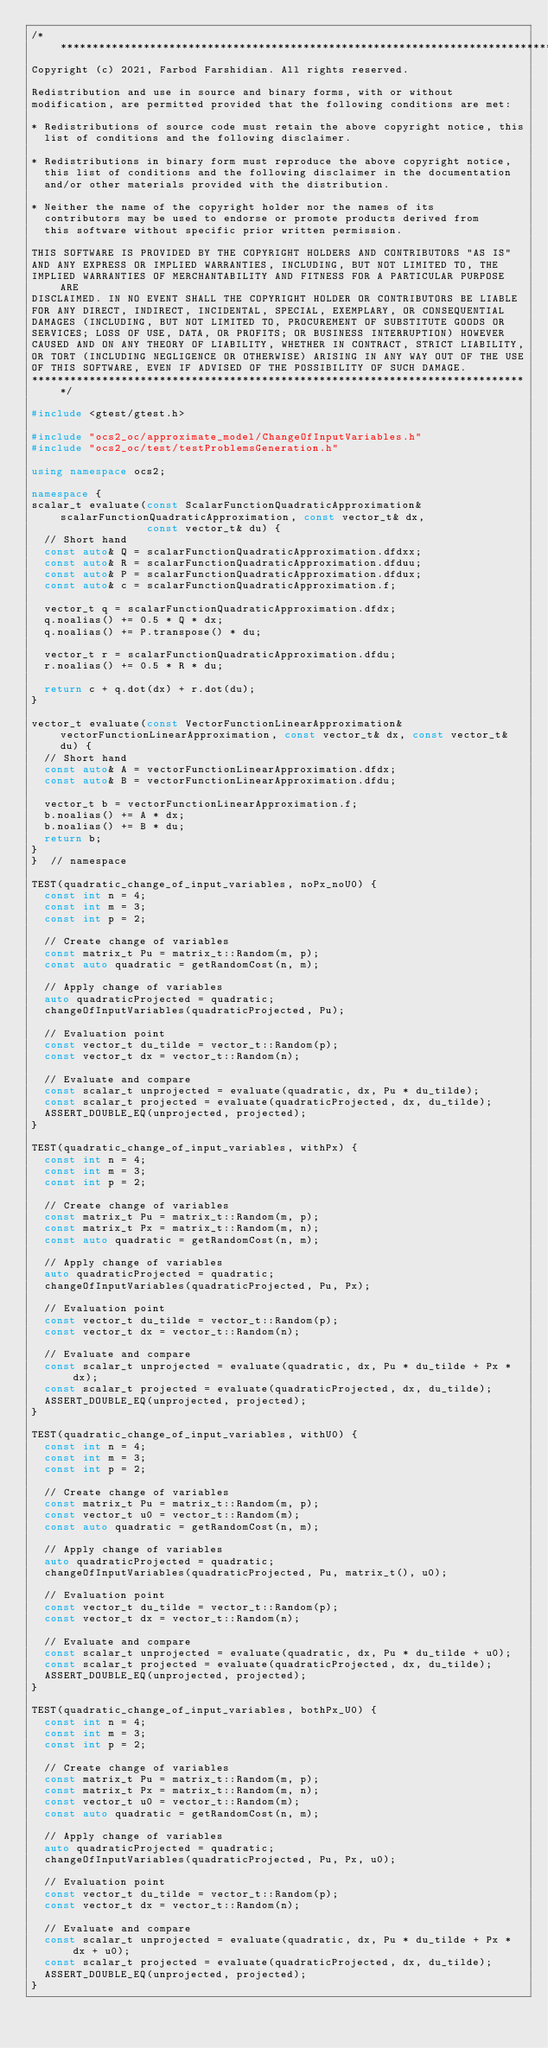<code> <loc_0><loc_0><loc_500><loc_500><_C++_>/******************************************************************************
Copyright (c) 2021, Farbod Farshidian. All rights reserved.

Redistribution and use in source and binary forms, with or without
modification, are permitted provided that the following conditions are met:

* Redistributions of source code must retain the above copyright notice, this
  list of conditions and the following disclaimer.

* Redistributions in binary form must reproduce the above copyright notice,
  this list of conditions and the following disclaimer in the documentation
  and/or other materials provided with the distribution.

* Neither the name of the copyright holder nor the names of its
  contributors may be used to endorse or promote products derived from
  this software without specific prior written permission.

THIS SOFTWARE IS PROVIDED BY THE COPYRIGHT HOLDERS AND CONTRIBUTORS "AS IS"
AND ANY EXPRESS OR IMPLIED WARRANTIES, INCLUDING, BUT NOT LIMITED TO, THE
IMPLIED WARRANTIES OF MERCHANTABILITY AND FITNESS FOR A PARTICULAR PURPOSE ARE
DISCLAIMED. IN NO EVENT SHALL THE COPYRIGHT HOLDER OR CONTRIBUTORS BE LIABLE
FOR ANY DIRECT, INDIRECT, INCIDENTAL, SPECIAL, EXEMPLARY, OR CONSEQUENTIAL
DAMAGES (INCLUDING, BUT NOT LIMITED TO, PROCUREMENT OF SUBSTITUTE GOODS OR
SERVICES; LOSS OF USE, DATA, OR PROFITS; OR BUSINESS INTERRUPTION) HOWEVER
CAUSED AND ON ANY THEORY OF LIABILITY, WHETHER IN CONTRACT, STRICT LIABILITY,
OR TORT (INCLUDING NEGLIGENCE OR OTHERWISE) ARISING IN ANY WAY OUT OF THE USE
OF THIS SOFTWARE, EVEN IF ADVISED OF THE POSSIBILITY OF SUCH DAMAGE.
******************************************************************************/

#include <gtest/gtest.h>

#include "ocs2_oc/approximate_model/ChangeOfInputVariables.h"
#include "ocs2_oc/test/testProblemsGeneration.h"

using namespace ocs2;

namespace {
scalar_t evaluate(const ScalarFunctionQuadraticApproximation& scalarFunctionQuadraticApproximation, const vector_t& dx,
                  const vector_t& du) {
  // Short hand
  const auto& Q = scalarFunctionQuadraticApproximation.dfdxx;
  const auto& R = scalarFunctionQuadraticApproximation.dfduu;
  const auto& P = scalarFunctionQuadraticApproximation.dfdux;
  const auto& c = scalarFunctionQuadraticApproximation.f;

  vector_t q = scalarFunctionQuadraticApproximation.dfdx;
  q.noalias() += 0.5 * Q * dx;
  q.noalias() += P.transpose() * du;

  vector_t r = scalarFunctionQuadraticApproximation.dfdu;
  r.noalias() += 0.5 * R * du;

  return c + q.dot(dx) + r.dot(du);
}

vector_t evaluate(const VectorFunctionLinearApproximation& vectorFunctionLinearApproximation, const vector_t& dx, const vector_t& du) {
  // Short hand
  const auto& A = vectorFunctionLinearApproximation.dfdx;
  const auto& B = vectorFunctionLinearApproximation.dfdu;

  vector_t b = vectorFunctionLinearApproximation.f;
  b.noalias() += A * dx;
  b.noalias() += B * du;
  return b;
}
}  // namespace

TEST(quadratic_change_of_input_variables, noPx_noU0) {
  const int n = 4;
  const int m = 3;
  const int p = 2;

  // Create change of variables
  const matrix_t Pu = matrix_t::Random(m, p);
  const auto quadratic = getRandomCost(n, m);

  // Apply change of variables
  auto quadraticProjected = quadratic;
  changeOfInputVariables(quadraticProjected, Pu);

  // Evaluation point
  const vector_t du_tilde = vector_t::Random(p);
  const vector_t dx = vector_t::Random(n);

  // Evaluate and compare
  const scalar_t unprojected = evaluate(quadratic, dx, Pu * du_tilde);
  const scalar_t projected = evaluate(quadraticProjected, dx, du_tilde);
  ASSERT_DOUBLE_EQ(unprojected, projected);
}

TEST(quadratic_change_of_input_variables, withPx) {
  const int n = 4;
  const int m = 3;
  const int p = 2;

  // Create change of variables
  const matrix_t Pu = matrix_t::Random(m, p);
  const matrix_t Px = matrix_t::Random(m, n);
  const auto quadratic = getRandomCost(n, m);

  // Apply change of variables
  auto quadraticProjected = quadratic;
  changeOfInputVariables(quadraticProjected, Pu, Px);

  // Evaluation point
  const vector_t du_tilde = vector_t::Random(p);
  const vector_t dx = vector_t::Random(n);

  // Evaluate and compare
  const scalar_t unprojected = evaluate(quadratic, dx, Pu * du_tilde + Px * dx);
  const scalar_t projected = evaluate(quadraticProjected, dx, du_tilde);
  ASSERT_DOUBLE_EQ(unprojected, projected);
}

TEST(quadratic_change_of_input_variables, withU0) {
  const int n = 4;
  const int m = 3;
  const int p = 2;

  // Create change of variables
  const matrix_t Pu = matrix_t::Random(m, p);
  const vector_t u0 = vector_t::Random(m);
  const auto quadratic = getRandomCost(n, m);

  // Apply change of variables
  auto quadraticProjected = quadratic;
  changeOfInputVariables(quadraticProjected, Pu, matrix_t(), u0);

  // Evaluation point
  const vector_t du_tilde = vector_t::Random(p);
  const vector_t dx = vector_t::Random(n);

  // Evaluate and compare
  const scalar_t unprojected = evaluate(quadratic, dx, Pu * du_tilde + u0);
  const scalar_t projected = evaluate(quadraticProjected, dx, du_tilde);
  ASSERT_DOUBLE_EQ(unprojected, projected);
}

TEST(quadratic_change_of_input_variables, bothPx_U0) {
  const int n = 4;
  const int m = 3;
  const int p = 2;

  // Create change of variables
  const matrix_t Pu = matrix_t::Random(m, p);
  const matrix_t Px = matrix_t::Random(m, n);
  const vector_t u0 = vector_t::Random(m);
  const auto quadratic = getRandomCost(n, m);

  // Apply change of variables
  auto quadraticProjected = quadratic;
  changeOfInputVariables(quadraticProjected, Pu, Px, u0);

  // Evaluation point
  const vector_t du_tilde = vector_t::Random(p);
  const vector_t dx = vector_t::Random(n);

  // Evaluate and compare
  const scalar_t unprojected = evaluate(quadratic, dx, Pu * du_tilde + Px * dx + u0);
  const scalar_t projected = evaluate(quadraticProjected, dx, du_tilde);
  ASSERT_DOUBLE_EQ(unprojected, projected);
}
</code> 